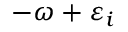<formula> <loc_0><loc_0><loc_500><loc_500>- \omega + \varepsilon _ { i }</formula> 